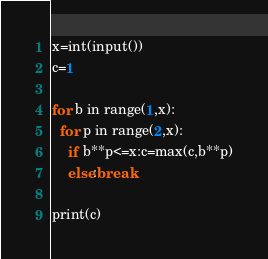Convert code to text. <code><loc_0><loc_0><loc_500><loc_500><_Python_>x=int(input())
c=1

for b in range(1,x):
  for p in range(2,x):
    if b**p<=x:c=max(c,b**p)
    else:break

print(c)</code> 